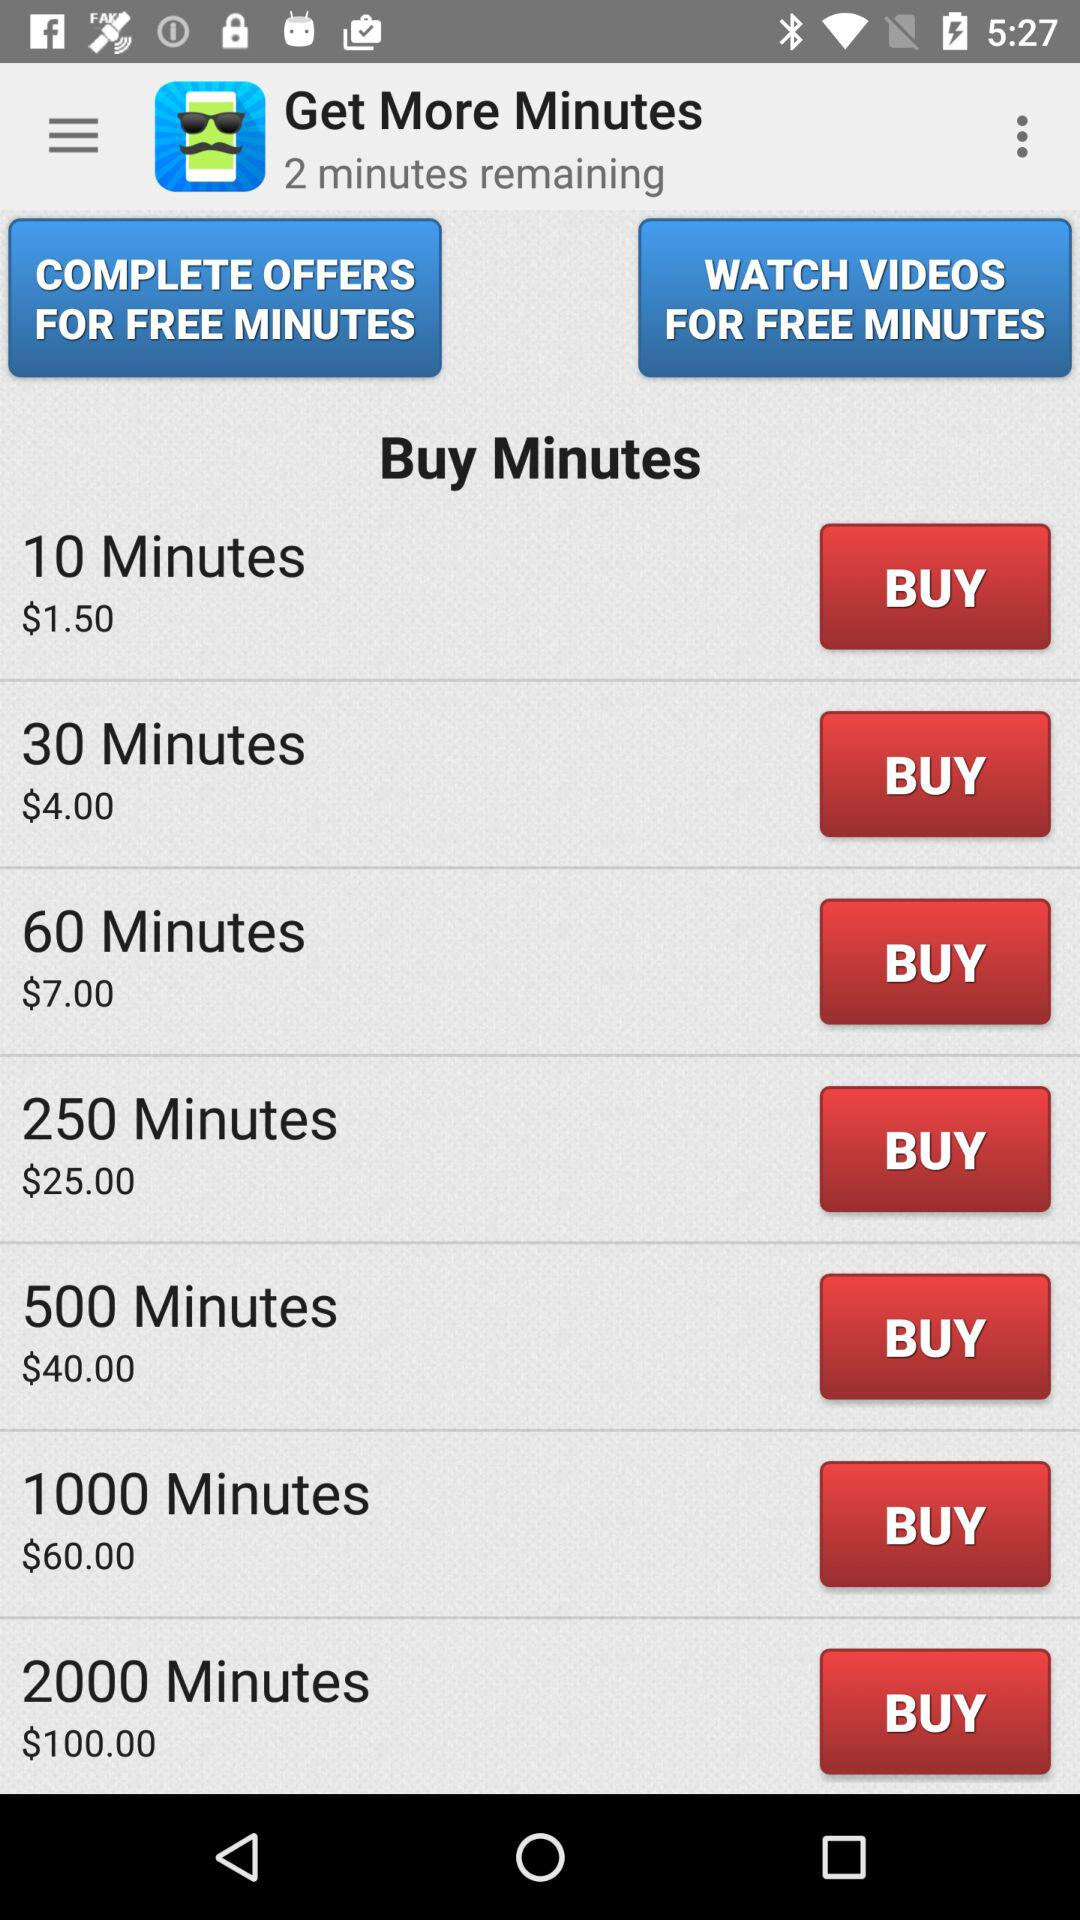How many minutes are remaining? The minutes remaining are 2. 